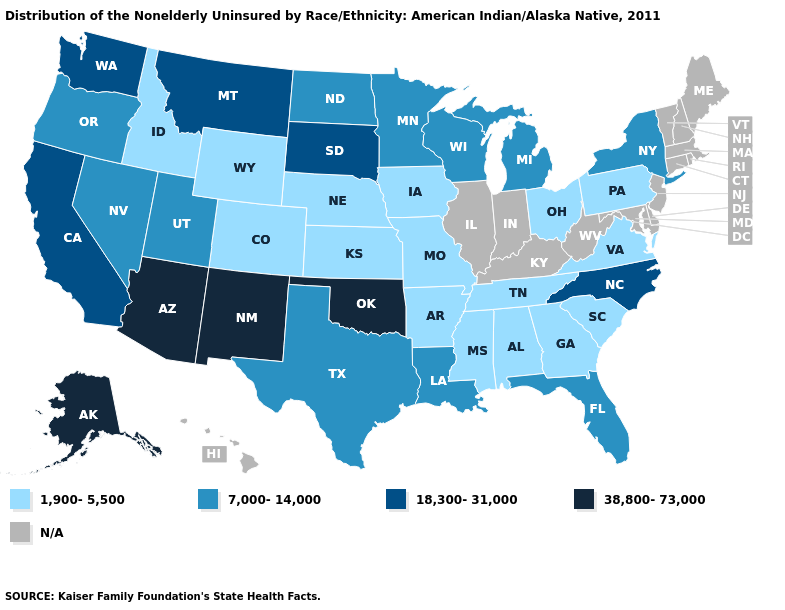What is the value of Arizona?
Be succinct. 38,800-73,000. What is the highest value in the West ?
Quick response, please. 38,800-73,000. What is the value of Delaware?
Quick response, please. N/A. Name the states that have a value in the range 1,900-5,500?
Answer briefly. Alabama, Arkansas, Colorado, Georgia, Idaho, Iowa, Kansas, Mississippi, Missouri, Nebraska, Ohio, Pennsylvania, South Carolina, Tennessee, Virginia, Wyoming. Which states hav the highest value in the Northeast?
Be succinct. New York. What is the value of Hawaii?
Short answer required. N/A. What is the lowest value in the Northeast?
Write a very short answer. 1,900-5,500. Does Mississippi have the lowest value in the USA?
Keep it brief. Yes. What is the value of Virginia?
Write a very short answer. 1,900-5,500. Which states hav the highest value in the Northeast?
Give a very brief answer. New York. Among the states that border New Mexico , does Oklahoma have the lowest value?
Concise answer only. No. What is the highest value in the South ?
Be succinct. 38,800-73,000. What is the lowest value in states that border Maryland?
Quick response, please. 1,900-5,500. What is the value of Virginia?
Be succinct. 1,900-5,500. 